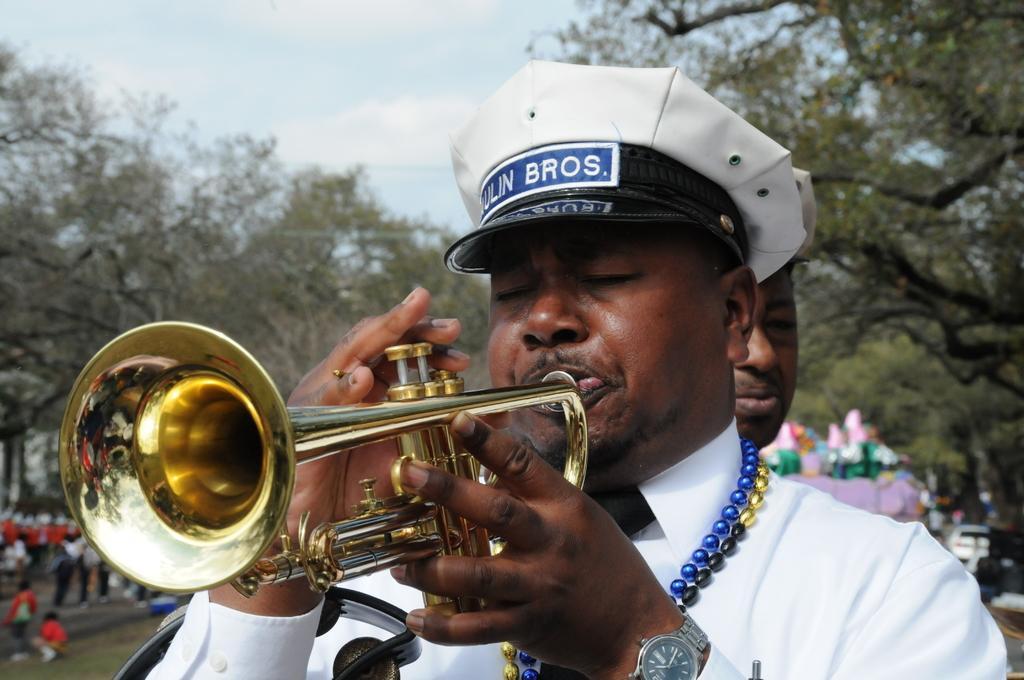Please provide a concise description of this image. In this picture I can see a man playing a trumpet, there are group of people, there are trees, and in the background there is the sky. 